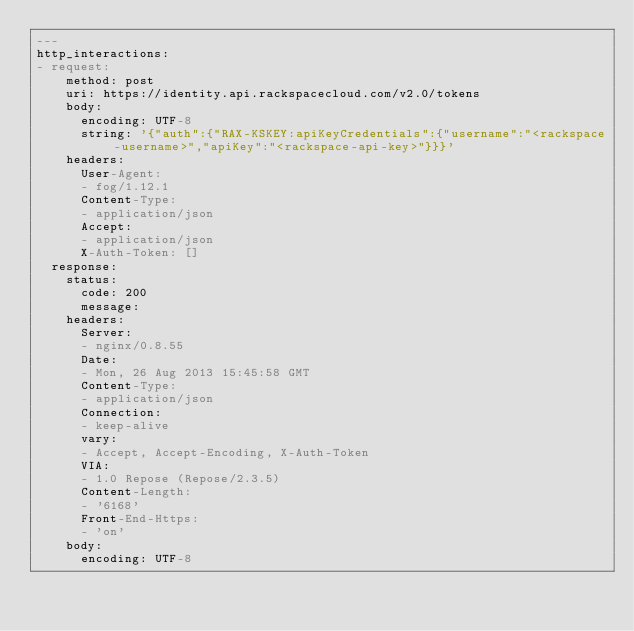<code> <loc_0><loc_0><loc_500><loc_500><_YAML_>---
http_interactions:
- request:
    method: post
    uri: https://identity.api.rackspacecloud.com/v2.0/tokens
    body:
      encoding: UTF-8
      string: '{"auth":{"RAX-KSKEY:apiKeyCredentials":{"username":"<rackspace-username>","apiKey":"<rackspace-api-key>"}}}'
    headers:
      User-Agent:
      - fog/1.12.1
      Content-Type:
      - application/json
      Accept:
      - application/json
      X-Auth-Token: []
  response:
    status:
      code: 200
      message: 
    headers:
      Server:
      - nginx/0.8.55
      Date:
      - Mon, 26 Aug 2013 15:45:58 GMT
      Content-Type:
      - application/json
      Connection:
      - keep-alive
      vary:
      - Accept, Accept-Encoding, X-Auth-Token
      VIA:
      - 1.0 Repose (Repose/2.3.5)
      Content-Length:
      - '6168'
      Front-End-Https:
      - 'on'
    body:
      encoding: UTF-8</code> 